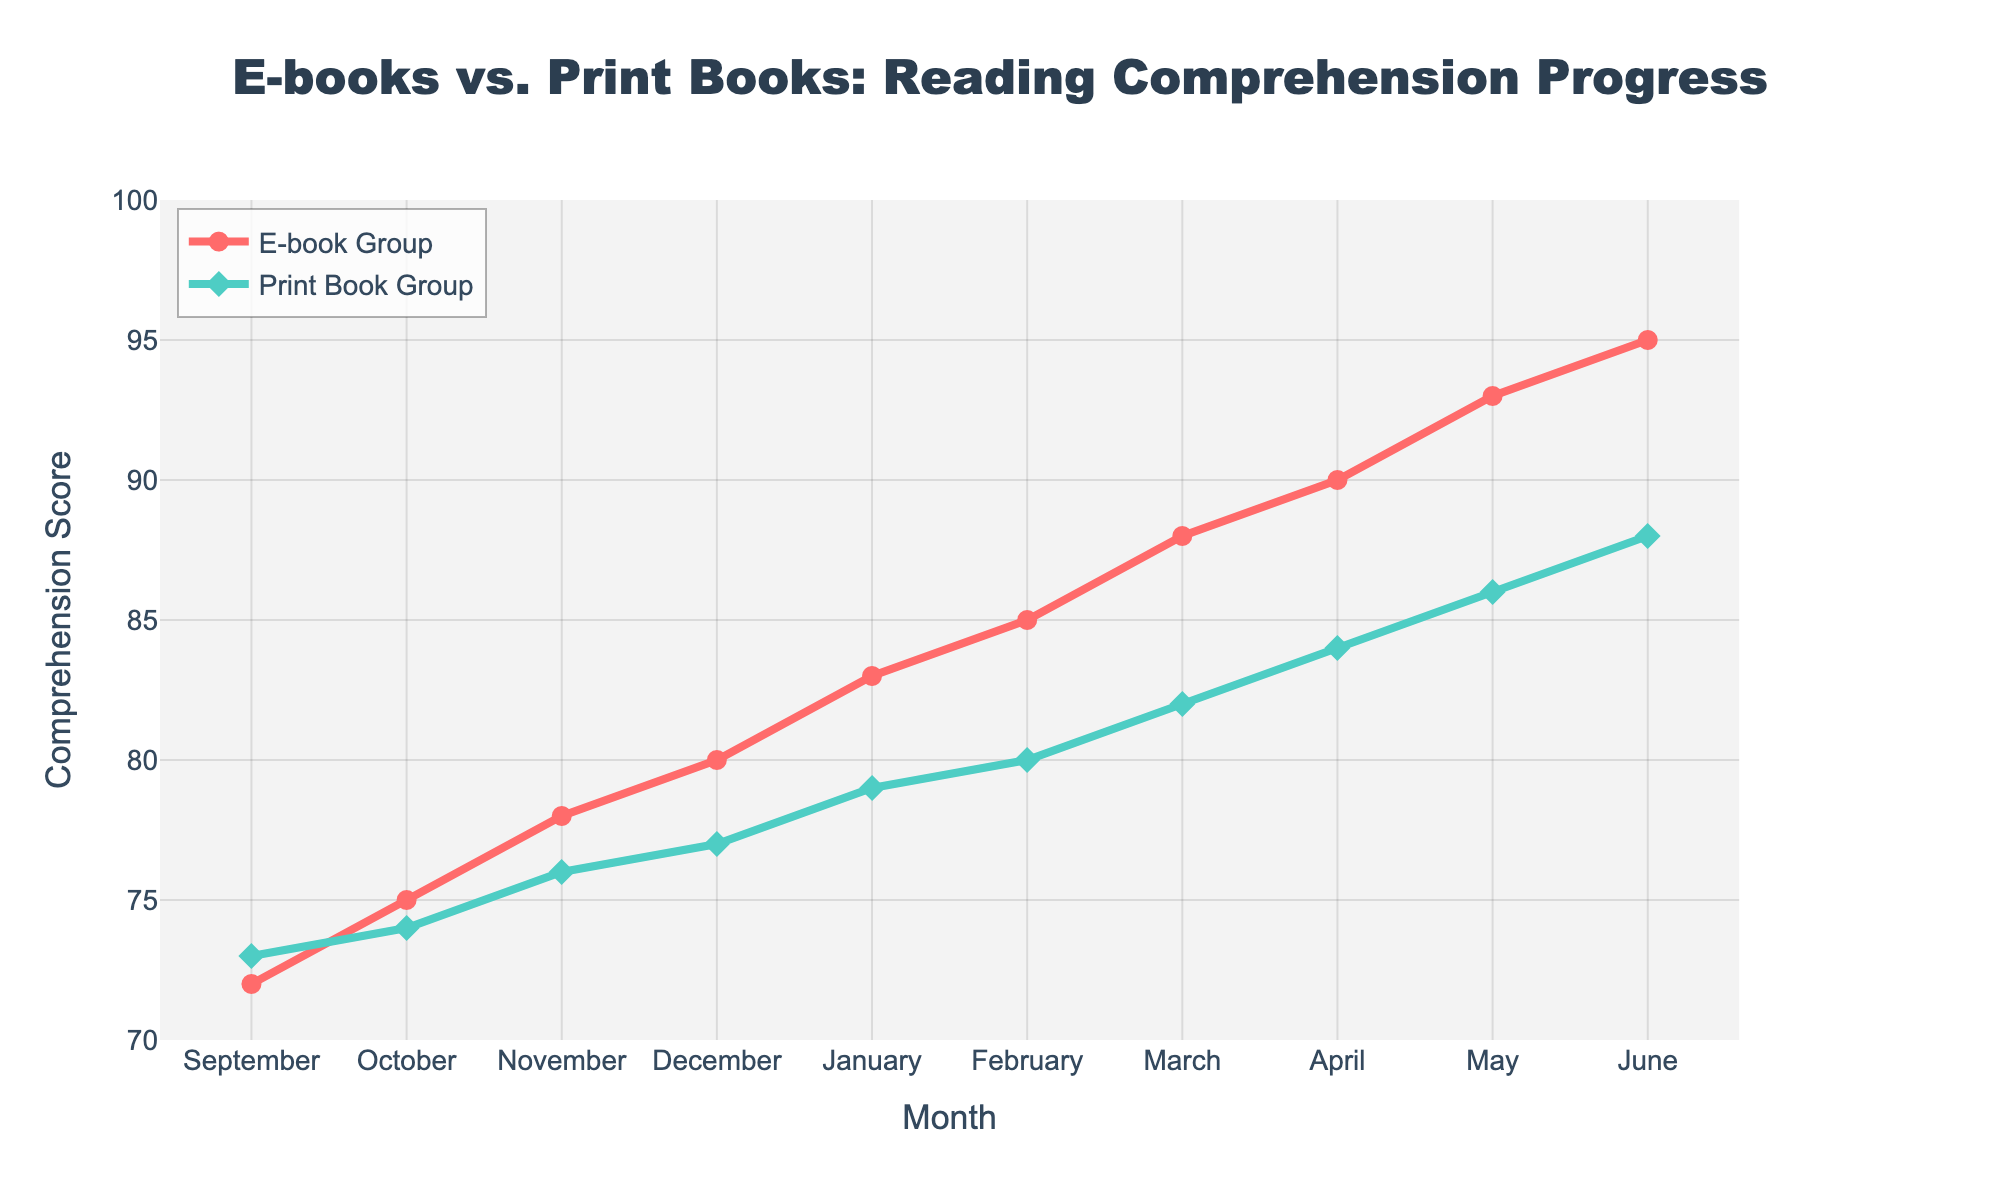What is the reading comprehension score for the E-book Group in March? To find the score, locate the point for the E-book Group (the red line) at the month marked "March". The y-axis value corresponding to this point is 88.
Answer: 88 Which student group has a higher reading comprehension score in May? Look at both the E-book Group's and the Print Book Group's values for May. The E-book Group (red line) has a score of 93, while the Print Book Group (green line) has a score of 86.
Answer: E-book Group By how many points did the Print Book Group's score increase from September to June? Find the Print Book Group’s scores for September and June (73 and 88, respectively). The increase is 88 - 73 = 15 points.
Answer: 15 What is the difference in reading comprehension scores between the E-book Group and Print Book Group in November? Locate the scores for both groups in November. The E-book Group has 78 and the Print Book Group has 76. The difference is 78 - 76 = 2.
Answer: 2 Which month shows the largest score difference between the E-book Group and the Print Book Group? Calculate the differences for each month: (3, 1, 2, 3, 4, 5, 6, 6, 7, 7). The largest difference is 7, occurring in both May and June.
Answer: May and June What is the average reading comprehension score for the Print Book Group over the entire school year? Sum all Print Book Group scores: 73 + 74 + 76 + 77 + 79 + 80 + 82 + 84 + 86 + 88 = 799. Divide by the number of months (10): 799 / 10 = 79.9.
Answer: 79.9 In which month does the E-book Group first surpass a reading comprehension score of 85? Identify the month when the E-book Group’s score first exceeds 85. The score surpasses 85 in February, with a score of 85.
Answer: February What is the total score difference from September to December for both groups combined? Calculate the difference for each group separately from September to December: (E-book: 80 - 72 = 8, Print Book: 77 - 73 = 4). Sum these differences: 8 + 4 = 12.
Answer: 12 What is the color of the line representing the Print Book Group? The Print Book Group is represented by the green line.
Answer: Green How many months have the same score difference between the two groups? Calculate the score difference for each month: (3, 1, 2, 3, 4, 5, 6, 6, 7, 7). Two months (May and June) share a score difference of 7 and two months (March and April) share a difference of 6.
Answer: 4 